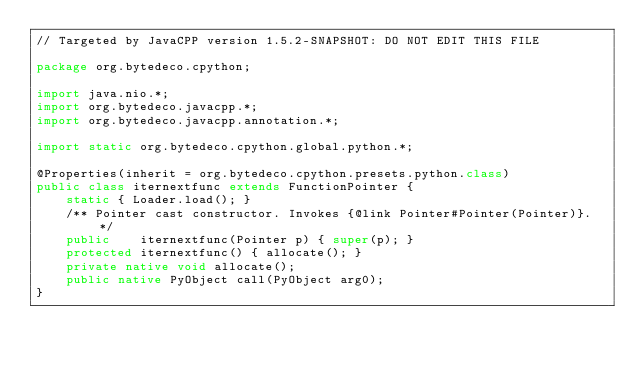<code> <loc_0><loc_0><loc_500><loc_500><_Java_>// Targeted by JavaCPP version 1.5.2-SNAPSHOT: DO NOT EDIT THIS FILE

package org.bytedeco.cpython;

import java.nio.*;
import org.bytedeco.javacpp.*;
import org.bytedeco.javacpp.annotation.*;

import static org.bytedeco.cpython.global.python.*;

@Properties(inherit = org.bytedeco.cpython.presets.python.class)
public class iternextfunc extends FunctionPointer {
    static { Loader.load(); }
    /** Pointer cast constructor. Invokes {@link Pointer#Pointer(Pointer)}. */
    public    iternextfunc(Pointer p) { super(p); }
    protected iternextfunc() { allocate(); }
    private native void allocate();
    public native PyObject call(PyObject arg0);
}
</code> 